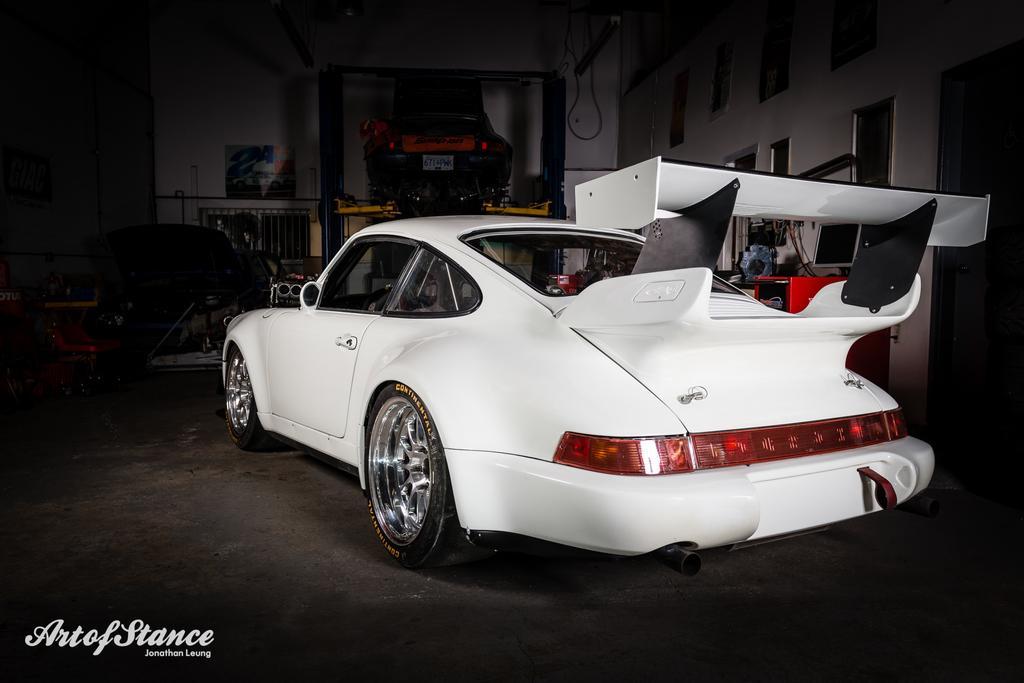Describe this image in one or two sentences. In the image there is a car and around the car there are some equipment. 